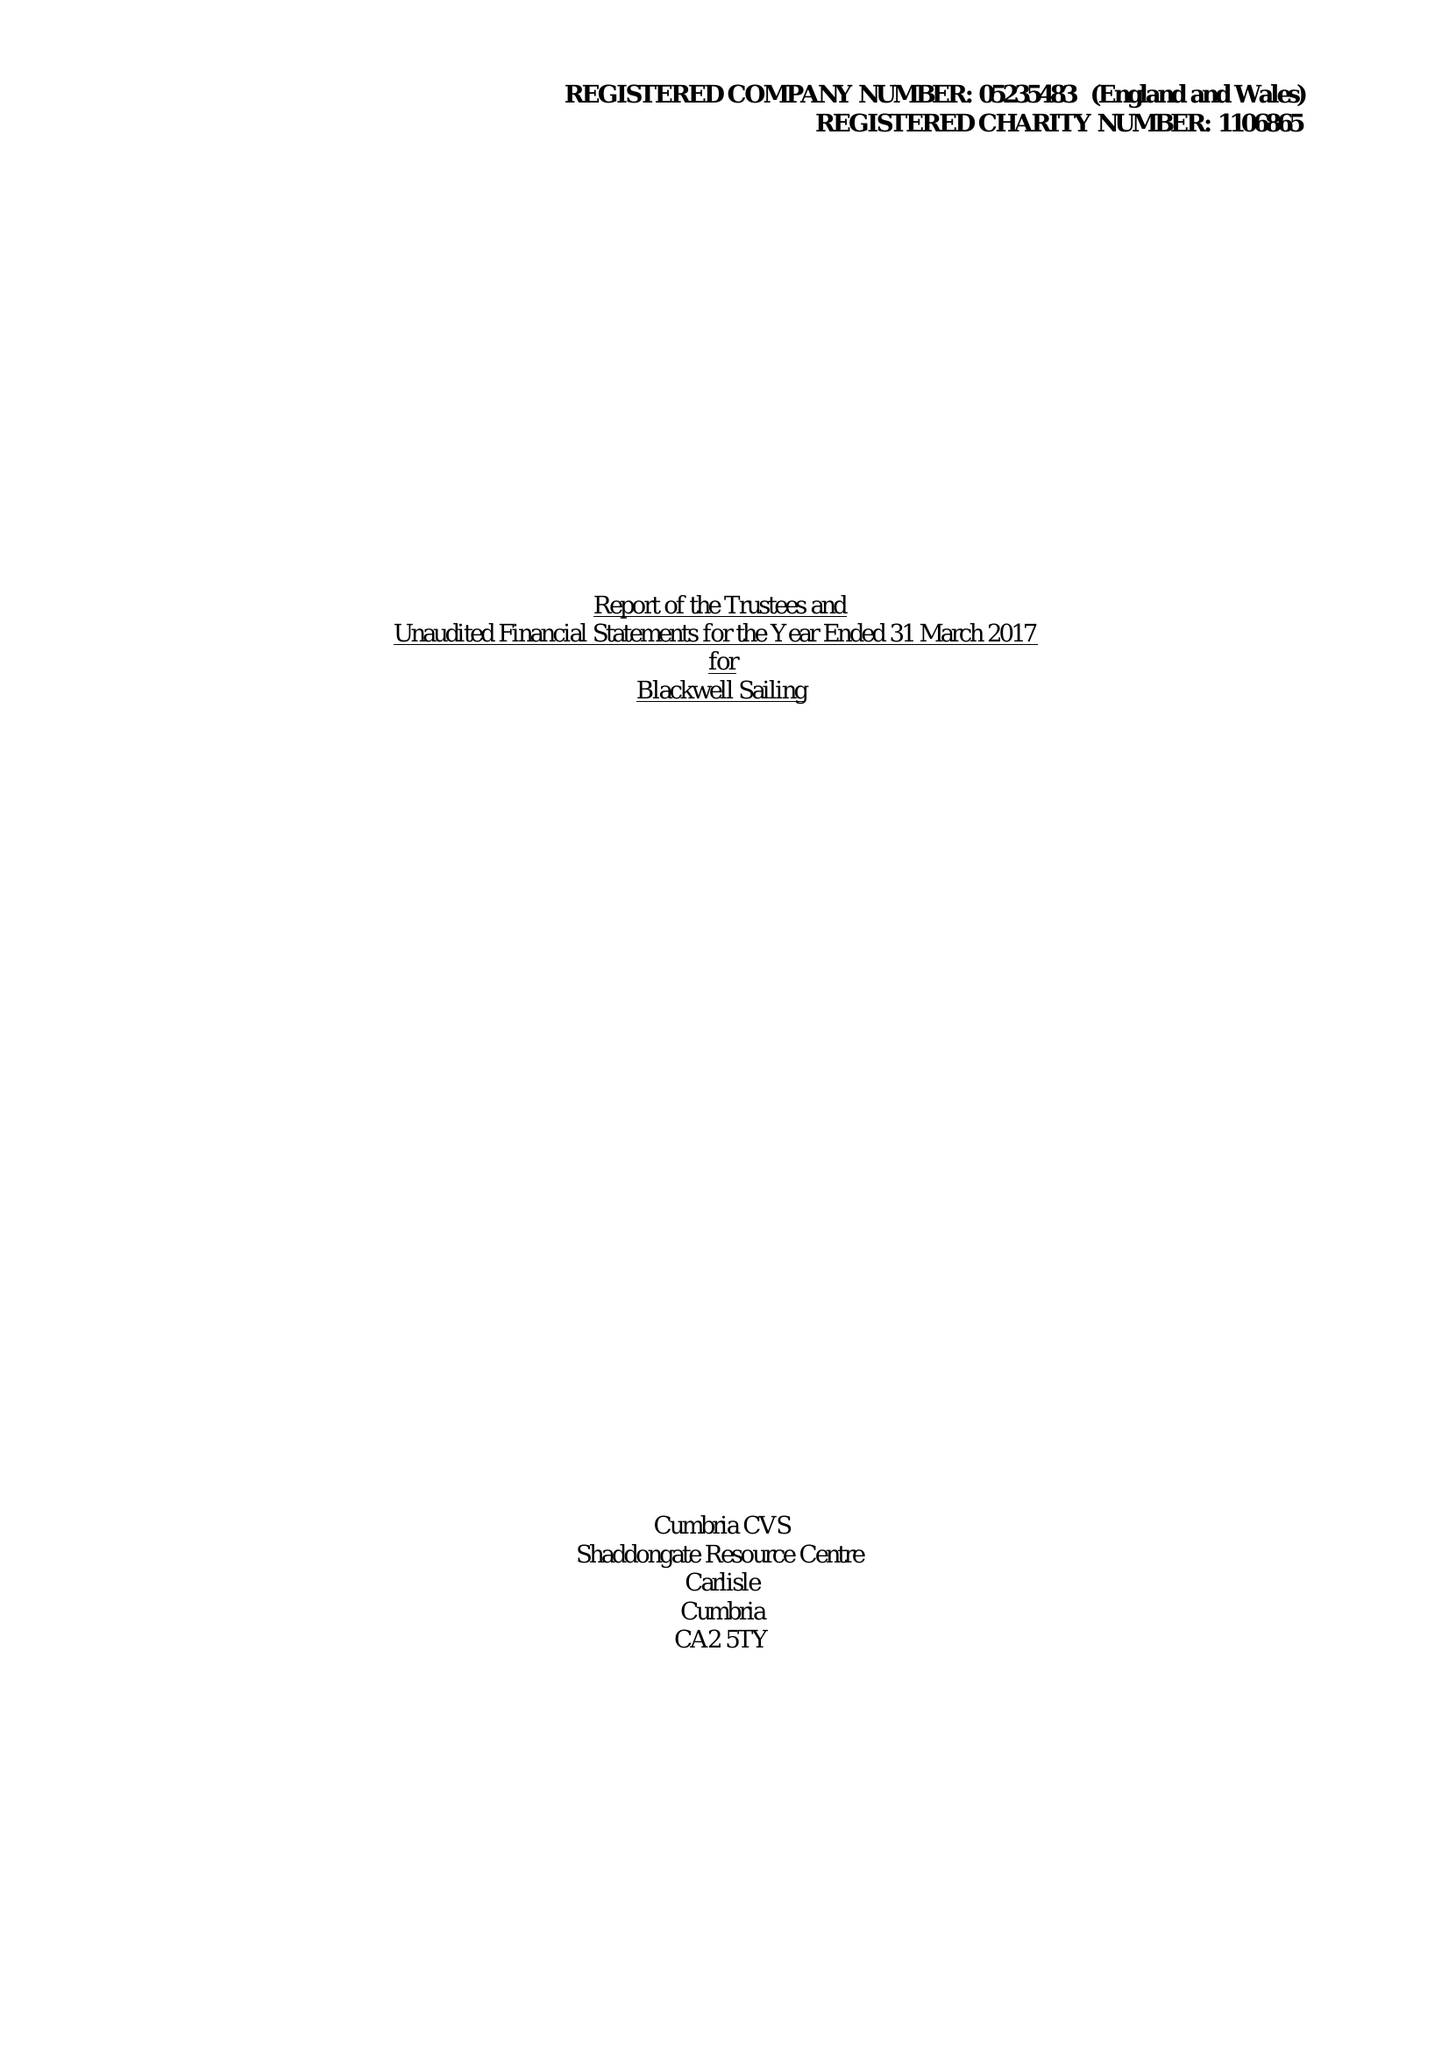What is the value for the spending_annually_in_british_pounds?
Answer the question using a single word or phrase. 71331.00 